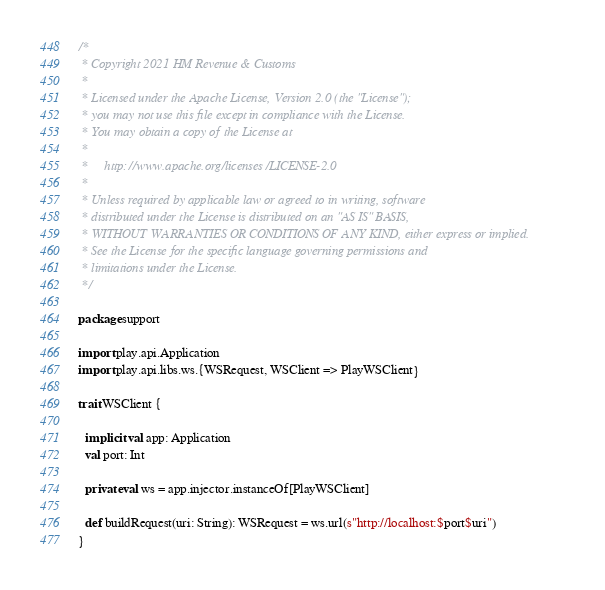<code> <loc_0><loc_0><loc_500><loc_500><_Scala_>/*
 * Copyright 2021 HM Revenue & Customs
 *
 * Licensed under the Apache License, Version 2.0 (the "License");
 * you may not use this file except in compliance with the License.
 * You may obtain a copy of the License at
 *
 *     http://www.apache.org/licenses/LICENSE-2.0
 *
 * Unless required by applicable law or agreed to in writing, software
 * distributed under the License is distributed on an "AS IS" BASIS,
 * WITHOUT WARRANTIES OR CONDITIONS OF ANY KIND, either express or implied.
 * See the License for the specific language governing permissions and
 * limitations under the License.
 */

package support

import play.api.Application
import play.api.libs.ws.{WSRequest, WSClient => PlayWSClient}

trait WSClient {

  implicit val app: Application
  val port: Int

  private val ws = app.injector.instanceOf[PlayWSClient]

  def buildRequest(uri: String): WSRequest = ws.url(s"http://localhost:$port$uri")
}
</code> 